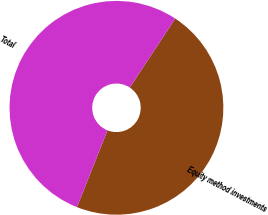<chart> <loc_0><loc_0><loc_500><loc_500><pie_chart><fcel>Equity method investments<fcel>Total<nl><fcel>46.76%<fcel>53.24%<nl></chart> 